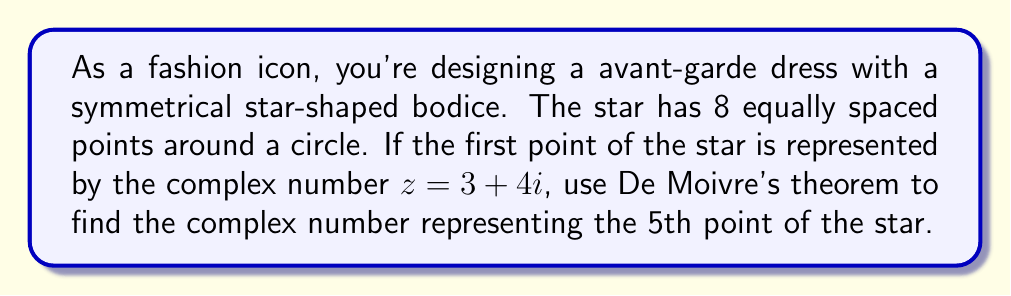Provide a solution to this math problem. Let's approach this step-by-step:

1) First, we need to understand what De Moivre's theorem states:
   $$(r(\cos\theta + i\sin\theta))^n = r^n(\cos(n\theta) + i\sin(n\theta))$$

2) In our case, we have 8 equally spaced points, so each point is rotated by $\frac{2\pi}{8} = \frac{\pi}{4}$ radians from the previous point.

3) To get from the 1st point to the 5th point, we need to rotate by $4 * \frac{\pi}{4} = \pi$ radians.

4) We need to express our initial point $z = 3 + 4i$ in polar form:
   $$r = \sqrt{3^2 + 4^2} = 5$$
   $$\theta = \arctan(\frac{4}{3}) \approx 0.927$$

   So, $z = 5(\cos(0.927) + i\sin(0.927))$

5) Now, we can apply De Moivre's theorem with $n = 1$ (as we're not raising to a power) and add $\pi$ to the angle:

   $$5(\cos(0.927 + \pi) + i\sin(0.927 + \pi))$$

6) Simplify:
   $$5(\cos(4.069) + i\sin(4.069))$$

7) Convert back to rectangular form:
   $$5\cos(4.069) + 5i\sin(4.069)$$

8) Calculate:
   $$-3 - 4i$$
Answer: $-3 - 4i$ 